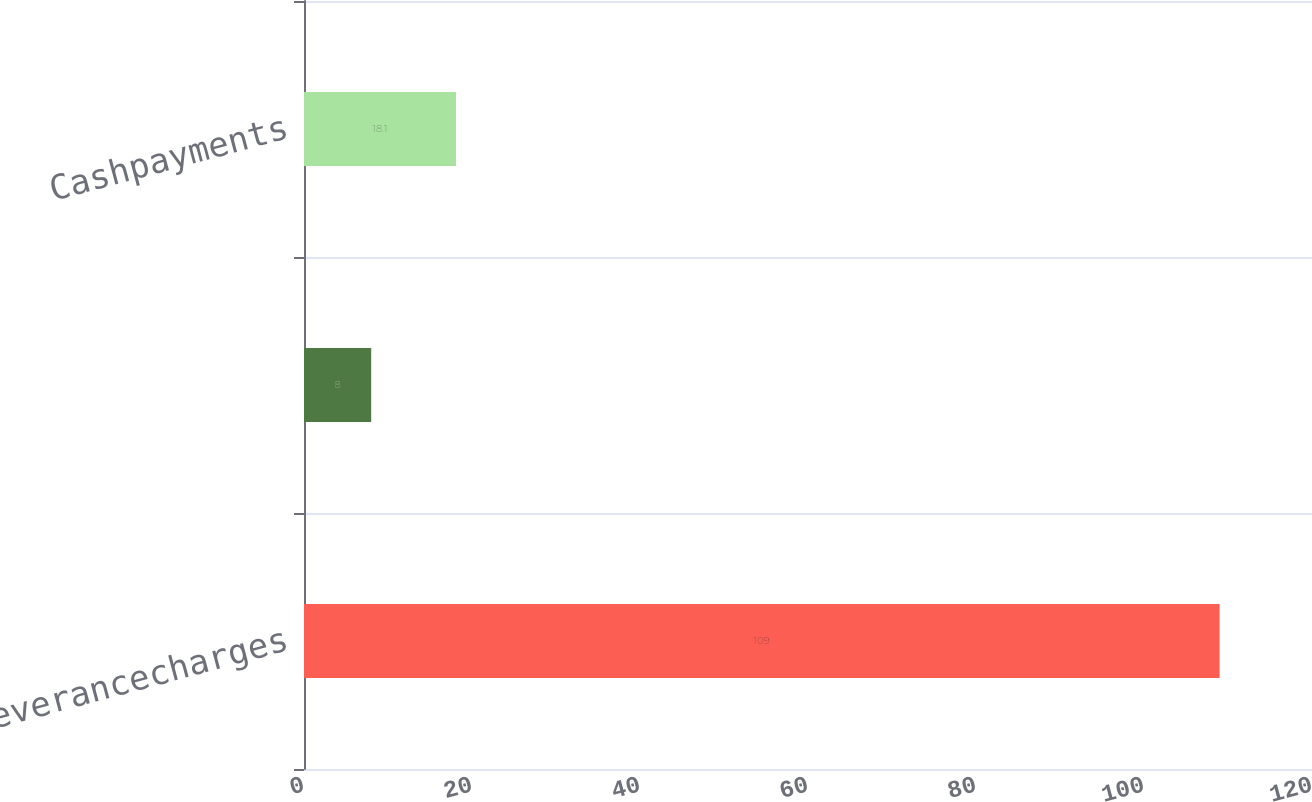Convert chart to OTSL. <chart><loc_0><loc_0><loc_500><loc_500><bar_chart><fcel>Severancecharges<fcel>Unnamed: 1<fcel>Cashpayments<nl><fcel>109<fcel>8<fcel>18.1<nl></chart> 